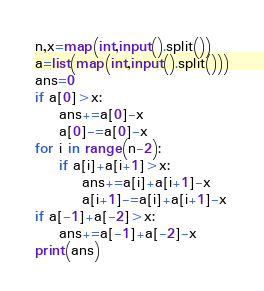Convert code to text. <code><loc_0><loc_0><loc_500><loc_500><_Python_>n,x=map(int,input().split())
a=list(map(int,input().split()))
ans=0
if a[0]>x:
    ans+=a[0]-x
    a[0]-=a[0]-x
for i in range(n-2):
    if a[i]+a[i+1]>x:
        ans+=a[i]+a[i+1]-x
        a[i+1]-=a[i]+a[i+1]-x
if a[-1]+a[-2]>x:
    ans+=a[-1]+a[-2]-x
print(ans)</code> 